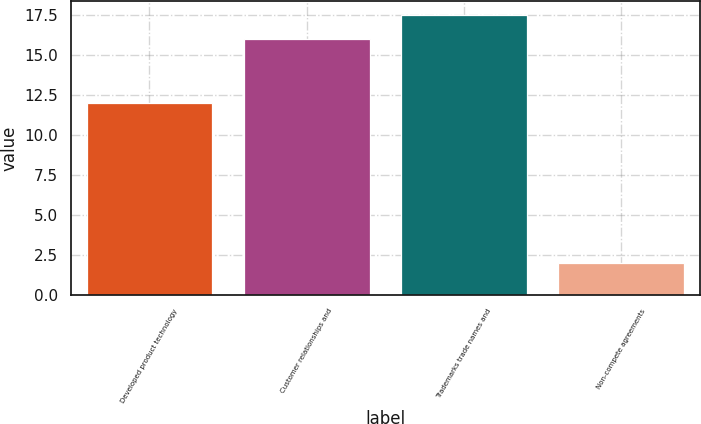<chart> <loc_0><loc_0><loc_500><loc_500><bar_chart><fcel>Developed product technology<fcel>Customer relationships and<fcel>Trademarks trade names and<fcel>Non-compete agreements<nl><fcel>12<fcel>16<fcel>17.5<fcel>2<nl></chart> 